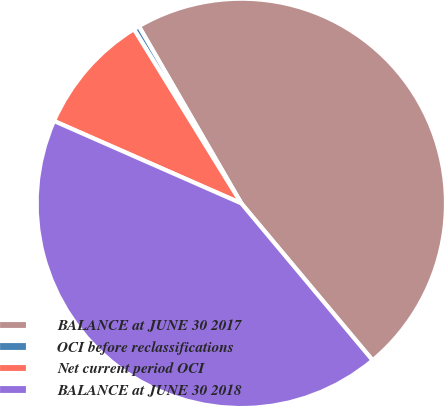Convert chart. <chart><loc_0><loc_0><loc_500><loc_500><pie_chart><fcel>BALANCE at JUNE 30 2017<fcel>OCI before reclassifications<fcel>Net current period OCI<fcel>BALANCE at JUNE 30 2018<nl><fcel>47.26%<fcel>0.45%<fcel>9.61%<fcel>42.68%<nl></chart> 